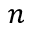Convert formula to latex. <formula><loc_0><loc_0><loc_500><loc_500>n</formula> 